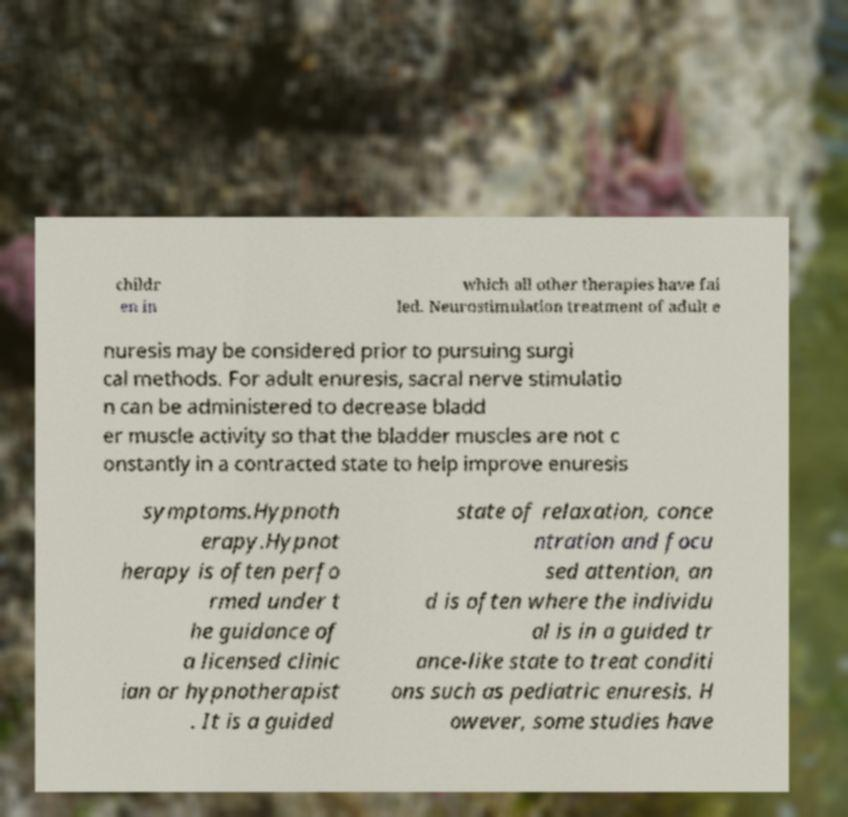There's text embedded in this image that I need extracted. Can you transcribe it verbatim? childr en in which all other therapies have fai led. Neurostimulation treatment of adult e nuresis may be considered prior to pursuing surgi cal methods. For adult enuresis, sacral nerve stimulatio n can be administered to decrease bladd er muscle activity so that the bladder muscles are not c onstantly in a contracted state to help improve enuresis symptoms.Hypnoth erapy.Hypnot herapy is often perfo rmed under t he guidance of a licensed clinic ian or hypnotherapist . It is a guided state of relaxation, conce ntration and focu sed attention, an d is often where the individu al is in a guided tr ance-like state to treat conditi ons such as pediatric enuresis. H owever, some studies have 